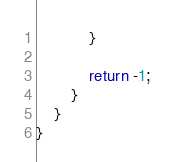<code> <loc_0><loc_0><loc_500><loc_500><_Java_>            }

            return -1;
        }
    }
}
</code> 